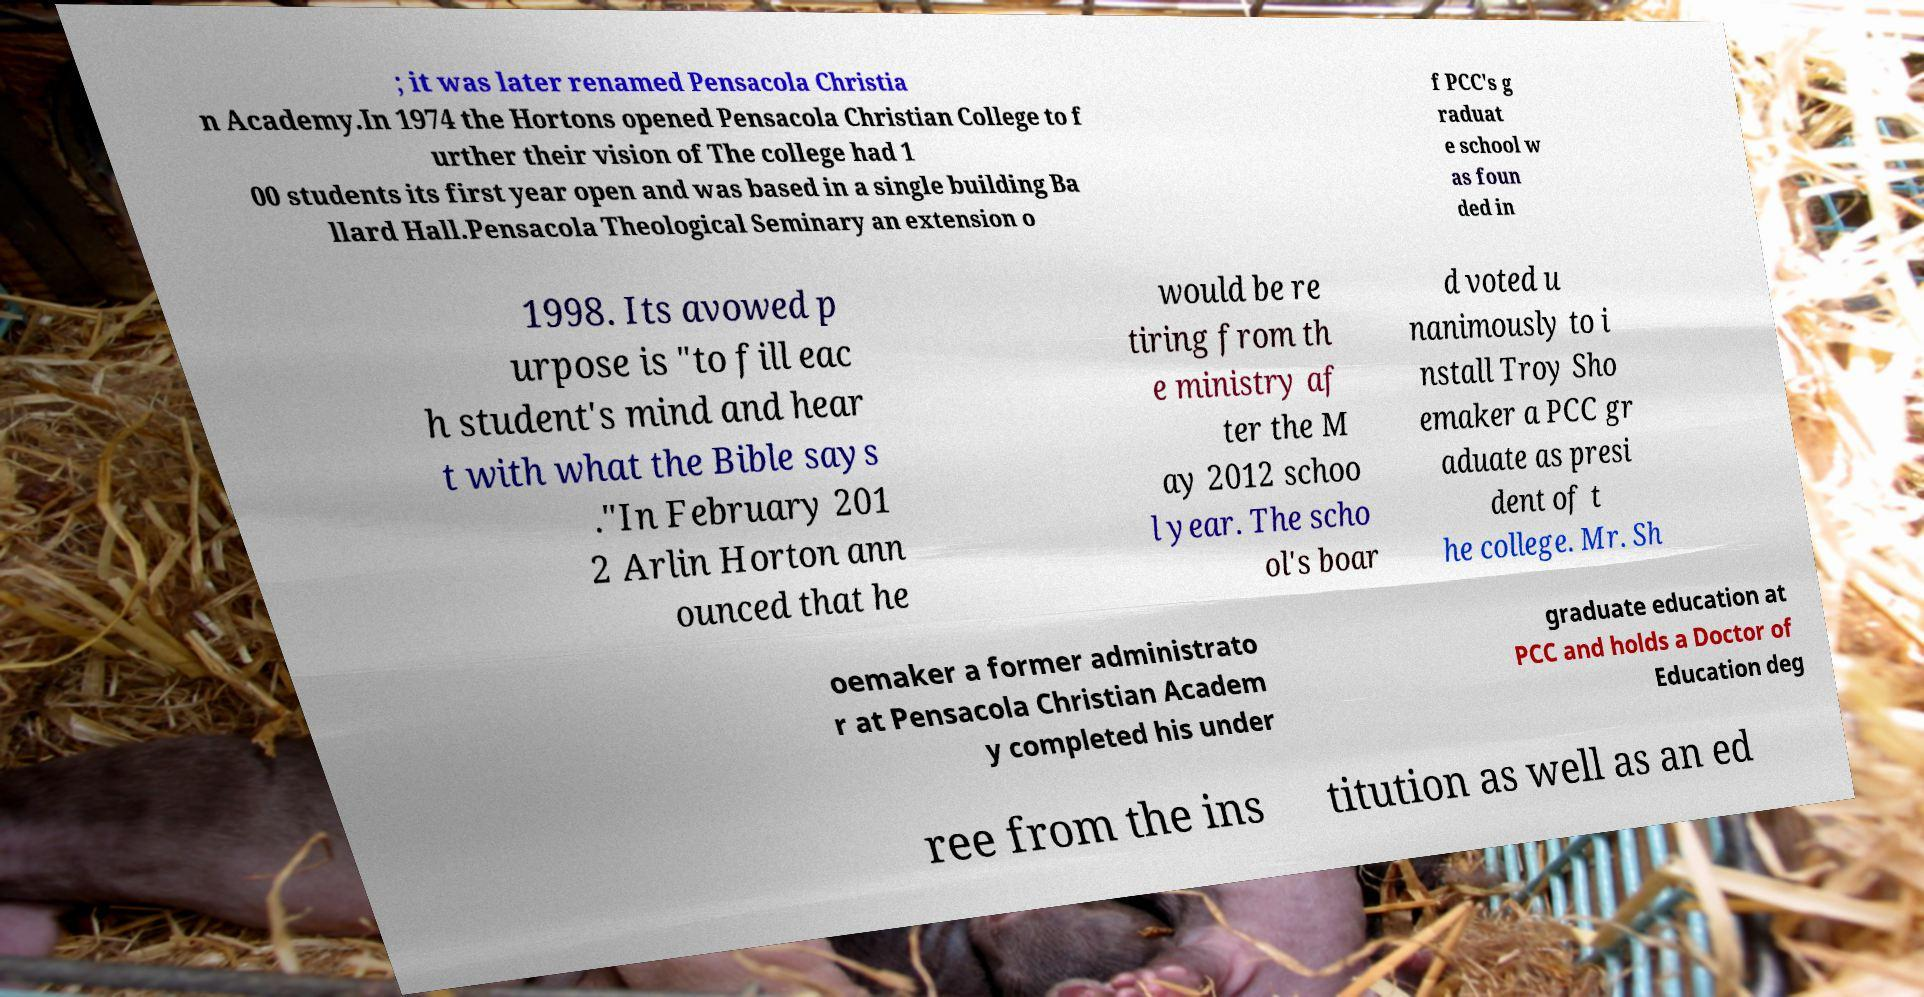For documentation purposes, I need the text within this image transcribed. Could you provide that? ; it was later renamed Pensacola Christia n Academy.In 1974 the Hortons opened Pensacola Christian College to f urther their vision of The college had 1 00 students its first year open and was based in a single building Ba llard Hall.Pensacola Theological Seminary an extension o f PCC's g raduat e school w as foun ded in 1998. Its avowed p urpose is "to fill eac h student's mind and hear t with what the Bible says ."In February 201 2 Arlin Horton ann ounced that he would be re tiring from th e ministry af ter the M ay 2012 schoo l year. The scho ol's boar d voted u nanimously to i nstall Troy Sho emaker a PCC gr aduate as presi dent of t he college. Mr. Sh oemaker a former administrato r at Pensacola Christian Academ y completed his under graduate education at PCC and holds a Doctor of Education deg ree from the ins titution as well as an ed 